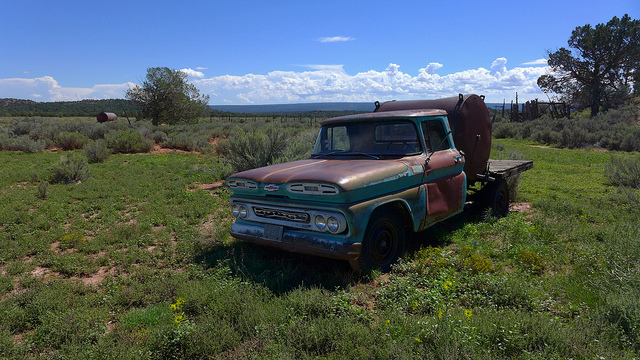<image>Has the older truck been well maintained mechanically? It's unknown whether the older truck has been well maintained mechanically. Has the older truck been well maintained mechanically? It is ambiguous whether the older truck has been well maintained mechanically. 